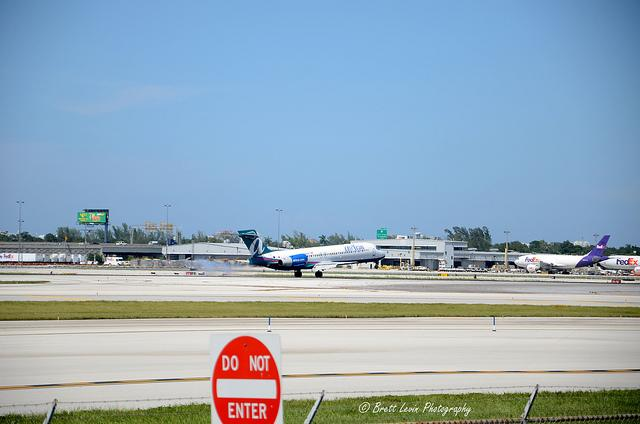What does the sign in front of the runways near the camera say? don't enter 